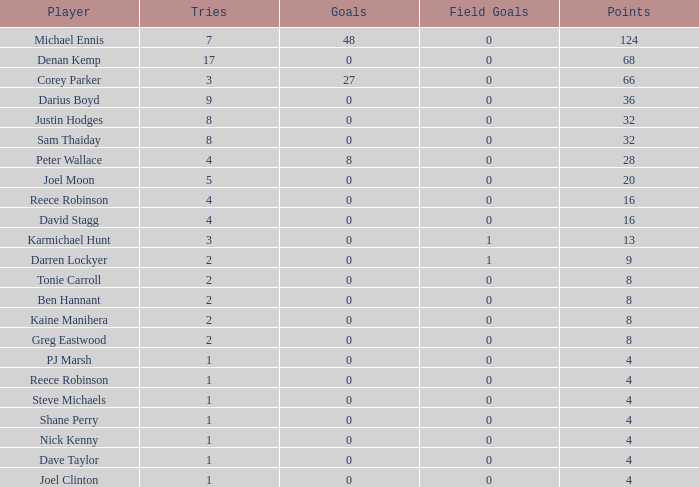For a player with more than 0 goals, 28 points, and over 0 field goals, what is the least number of tries they have? None. 